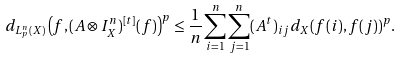Convert formula to latex. <formula><loc_0><loc_0><loc_500><loc_500>d _ { L _ { p } ^ { n } ( X ) } \left ( f , ( A \otimes I _ { X } ^ { n } ) ^ { [ t ] } ( f ) \right ) ^ { p } \leq \frac { 1 } { n } \sum _ { i = 1 } ^ { n } \sum _ { j = 1 } ^ { n } ( A ^ { t } ) _ { i j } d _ { X } ( f ( i ) , f ( j ) ) ^ { p } .</formula> 